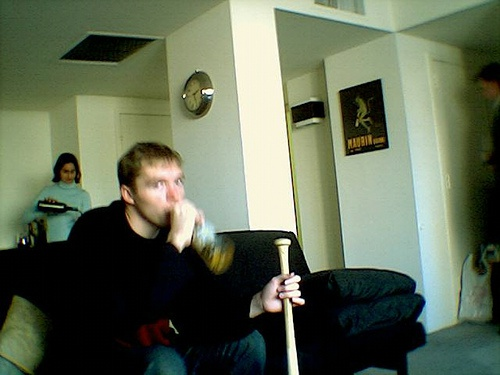Describe the objects in this image and their specific colors. I can see people in darkgreen, black, lightgray, and tan tones, couch in darkgreen, black, gray, and darkgray tones, people in darkgreen, teal, and black tones, people in darkgreen and black tones, and bottle in darkgreen, olive, black, gray, and lightblue tones in this image. 